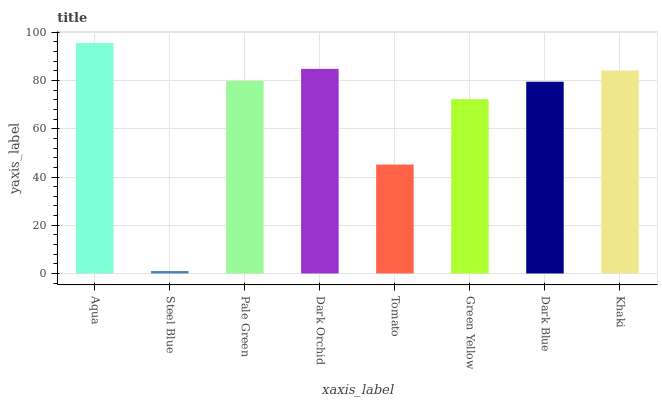Is Steel Blue the minimum?
Answer yes or no. Yes. Is Aqua the maximum?
Answer yes or no. Yes. Is Pale Green the minimum?
Answer yes or no. No. Is Pale Green the maximum?
Answer yes or no. No. Is Pale Green greater than Steel Blue?
Answer yes or no. Yes. Is Steel Blue less than Pale Green?
Answer yes or no. Yes. Is Steel Blue greater than Pale Green?
Answer yes or no. No. Is Pale Green less than Steel Blue?
Answer yes or no. No. Is Pale Green the high median?
Answer yes or no. Yes. Is Dark Blue the low median?
Answer yes or no. Yes. Is Aqua the high median?
Answer yes or no. No. Is Khaki the low median?
Answer yes or no. No. 